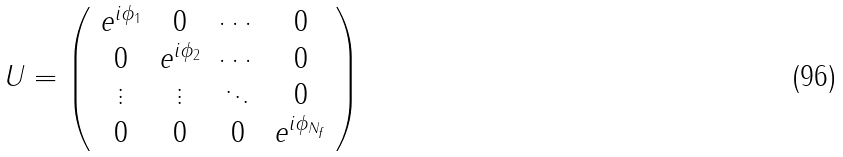<formula> <loc_0><loc_0><loc_500><loc_500>U = \left ( \begin{array} { c c c c } e ^ { i \phi _ { 1 } } & 0 & \cdots & 0 \\ 0 & e ^ { i \phi _ { 2 } } & \cdots & 0 \\ \vdots & \vdots & \ddots & 0 \\ 0 & 0 & 0 & e ^ { i \phi _ { N _ { f } } } \end{array} \right )</formula> 